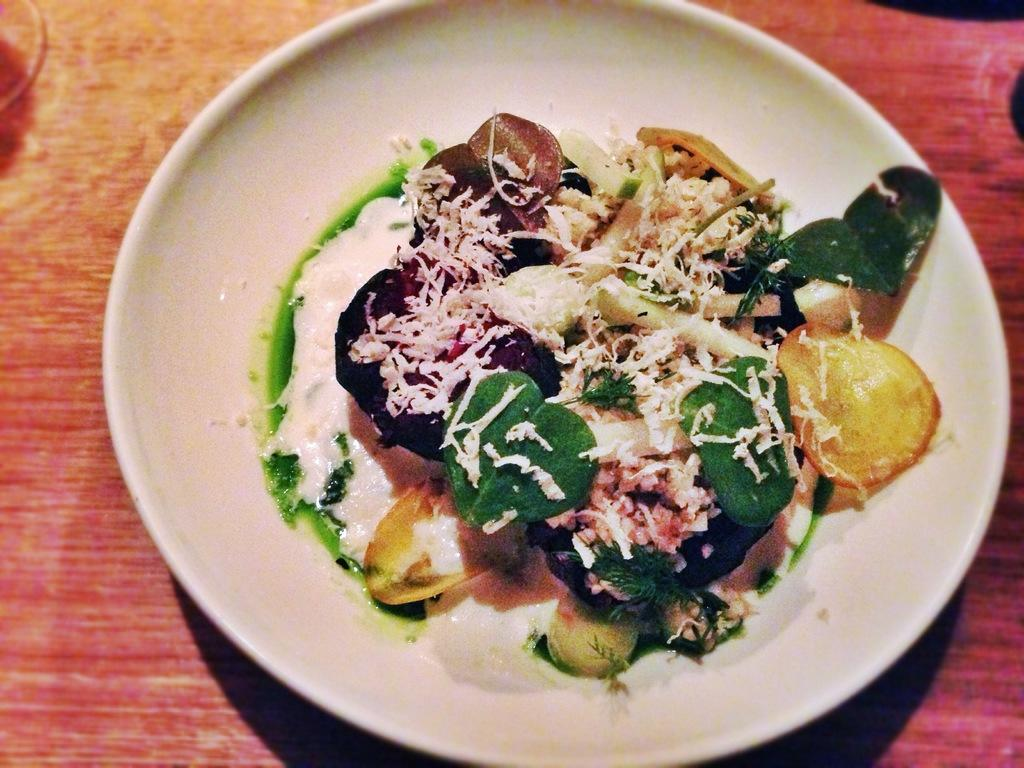What is on the surface in the image? There is a white plate on the surface in the image. What is the color of the plate? The plate is white. What is on the plate? There is a food item on the plate. What type of jewel is on the plate in the image? There is no jewel present on the plate in the image; it contains a food item. 